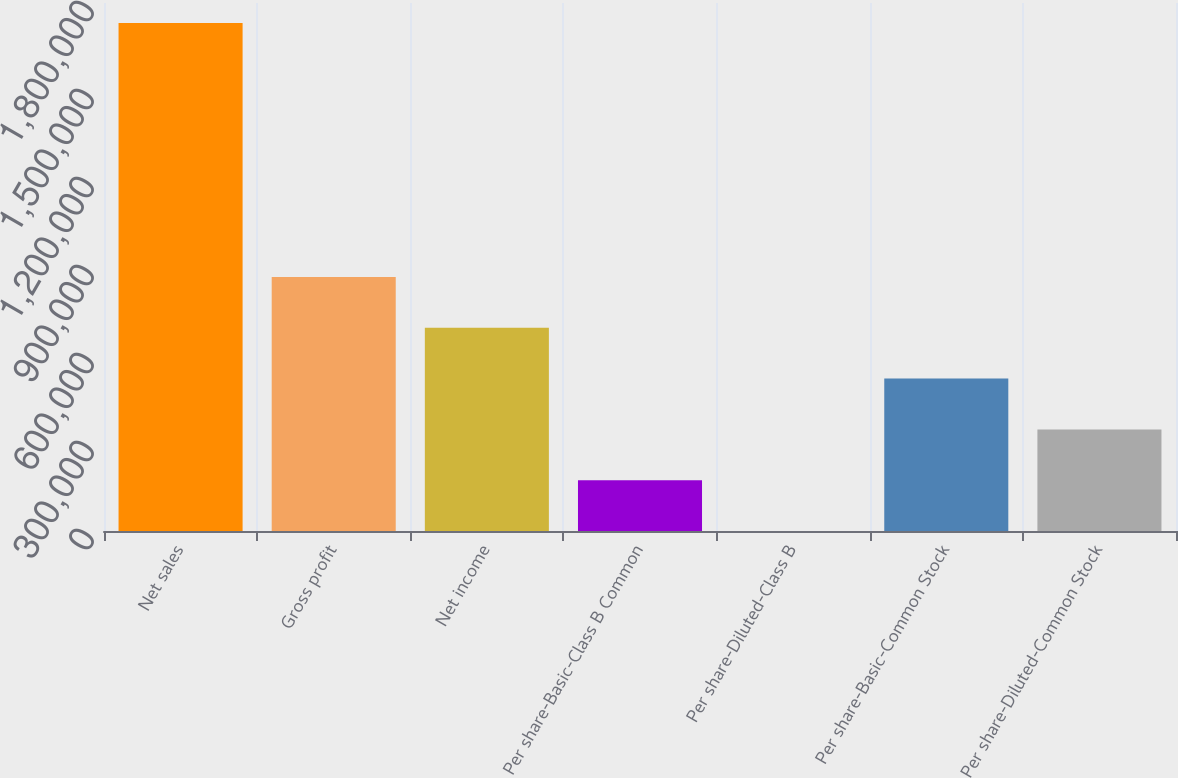<chart> <loc_0><loc_0><loc_500><loc_500><bar_chart><fcel>Net sales<fcel>Gross profit<fcel>Net income<fcel>Per share-Basic-Class B Common<fcel>Per share-Diluted-Class B<fcel>Per share-Basic-Common Stock<fcel>Per share-Diluted-Common Stock<nl><fcel>1.73206e+06<fcel>866032<fcel>692826<fcel>173207<fcel>0.81<fcel>519620<fcel>346413<nl></chart> 